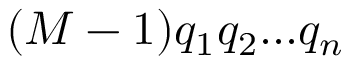<formula> <loc_0><loc_0><loc_500><loc_500>( M - 1 ) q _ { 1 } q _ { 2 } \dots q _ { n }</formula> 